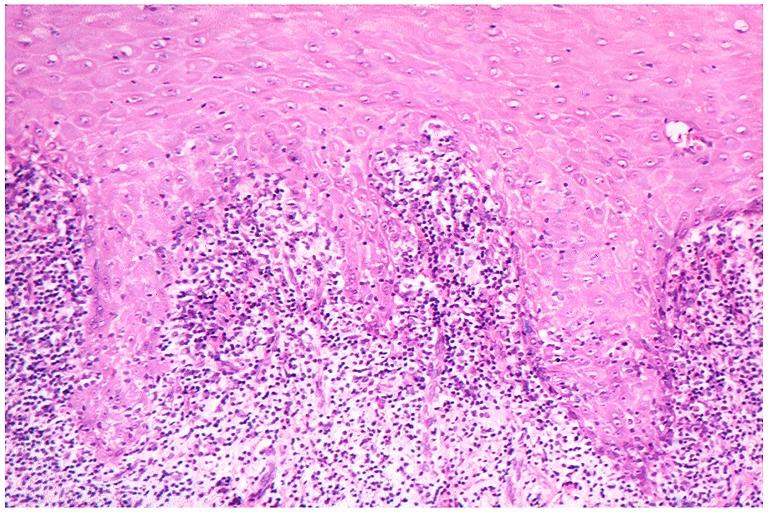s history present?
Answer the question using a single word or phrase. No 